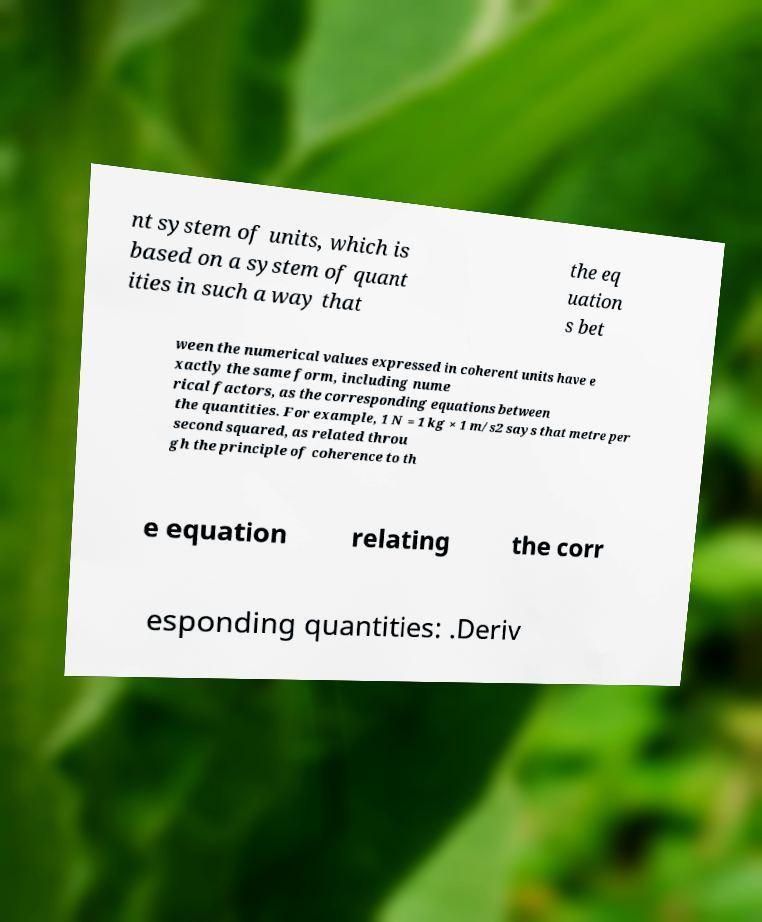For documentation purposes, I need the text within this image transcribed. Could you provide that? nt system of units, which is based on a system of quant ities in such a way that the eq uation s bet ween the numerical values expressed in coherent units have e xactly the same form, including nume rical factors, as the corresponding equations between the quantities. For example, 1 N = 1 kg × 1 m/s2 says that metre per second squared, as related throu gh the principle of coherence to th e equation relating the corr esponding quantities: .Deriv 